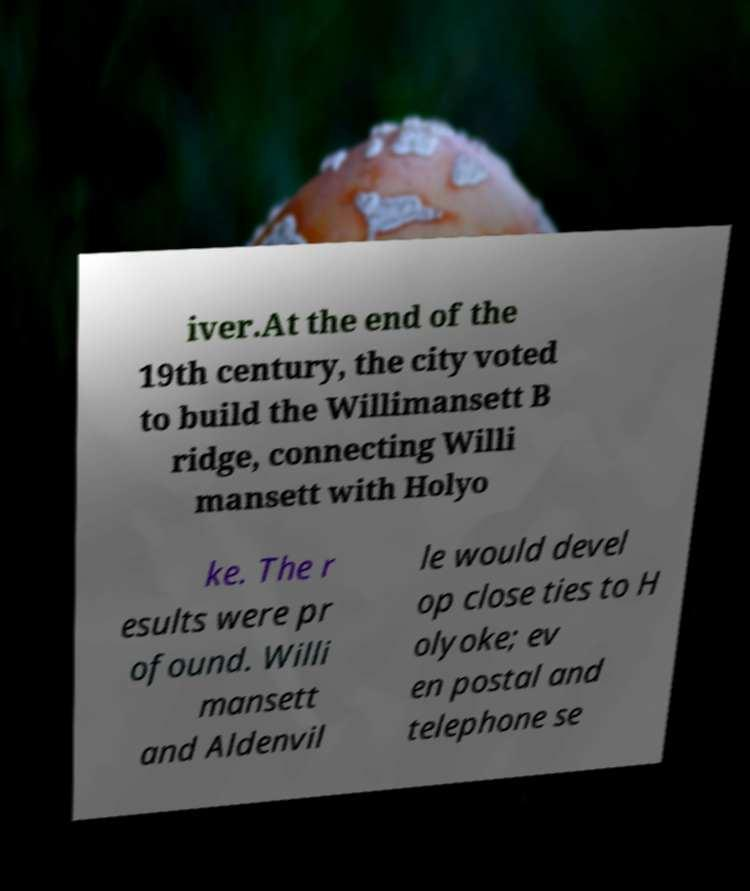I need the written content from this picture converted into text. Can you do that? iver.At the end of the 19th century, the city voted to build the Willimansett B ridge, connecting Willi mansett with Holyo ke. The r esults were pr ofound. Willi mansett and Aldenvil le would devel op close ties to H olyoke; ev en postal and telephone se 